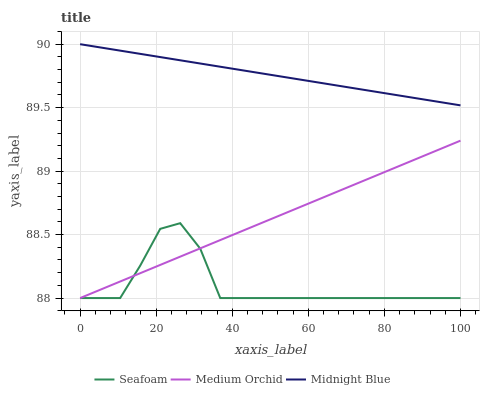Does Seafoam have the minimum area under the curve?
Answer yes or no. Yes. Does Midnight Blue have the maximum area under the curve?
Answer yes or no. Yes. Does Midnight Blue have the minimum area under the curve?
Answer yes or no. No. Does Seafoam have the maximum area under the curve?
Answer yes or no. No. Is Midnight Blue the smoothest?
Answer yes or no. Yes. Is Seafoam the roughest?
Answer yes or no. Yes. Is Seafoam the smoothest?
Answer yes or no. No. Is Midnight Blue the roughest?
Answer yes or no. No. Does Midnight Blue have the lowest value?
Answer yes or no. No. Does Midnight Blue have the highest value?
Answer yes or no. Yes. Does Seafoam have the highest value?
Answer yes or no. No. Is Medium Orchid less than Midnight Blue?
Answer yes or no. Yes. Is Midnight Blue greater than Seafoam?
Answer yes or no. Yes. Does Seafoam intersect Medium Orchid?
Answer yes or no. Yes. Is Seafoam less than Medium Orchid?
Answer yes or no. No. Is Seafoam greater than Medium Orchid?
Answer yes or no. No. Does Medium Orchid intersect Midnight Blue?
Answer yes or no. No. 